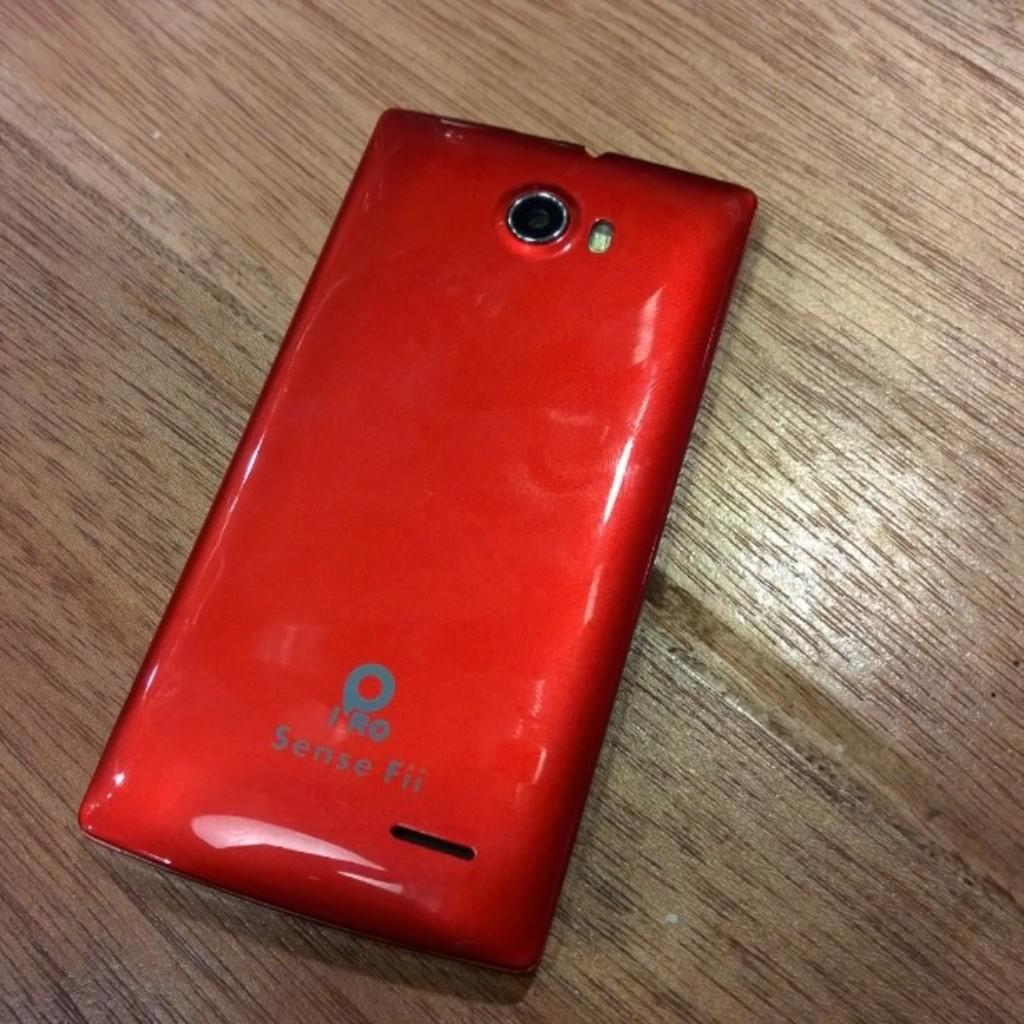Provide a one-sentence caption for the provided image. The back side of a red IRO Sense Fii smart phone appears to be in good condition. 